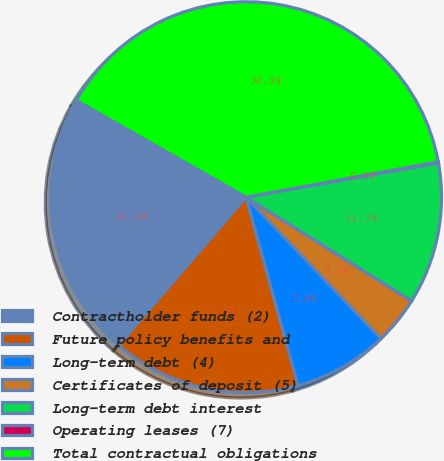<chart> <loc_0><loc_0><loc_500><loc_500><pie_chart><fcel>Contractholder funds (2)<fcel>Future policy benefits and<fcel>Long-term debt (4)<fcel>Certificates of deposit (5)<fcel>Long-term debt interest<fcel>Operating leases (7)<fcel>Total contractual obligations<nl><fcel>21.94%<fcel>15.59%<fcel>7.84%<fcel>3.96%<fcel>11.72%<fcel>0.09%<fcel>38.85%<nl></chart> 